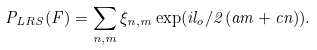Convert formula to latex. <formula><loc_0><loc_0><loc_500><loc_500>P _ { L R S } ( F ) = \sum _ { n , m } \xi _ { n , m } \exp ( i l _ { o } / 2 ( a m + c n ) ) .</formula> 